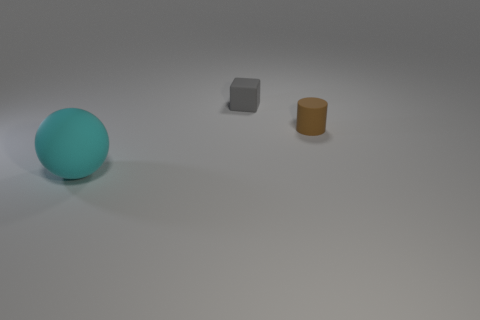How big is the matte ball?
Provide a short and direct response. Large. Are there more balls that are in front of the cylinder than purple rubber spheres?
Ensure brevity in your answer.  Yes. Are there an equal number of brown matte cylinders that are left of the small brown rubber cylinder and matte objects that are on the left side of the gray matte object?
Offer a very short reply. No. The object that is in front of the tiny matte cube and on the left side of the small brown cylinder is what color?
Your response must be concise. Cyan. Is there any other thing that has the same size as the sphere?
Your response must be concise. No. Is the number of small things on the left side of the brown object greater than the number of tiny rubber things that are in front of the cyan sphere?
Provide a short and direct response. Yes. There is a rubber thing right of the matte block; is it the same size as the cyan rubber sphere?
Your response must be concise. No. How many cyan balls are on the left side of the tiny thing that is in front of the object behind the tiny brown rubber object?
Your answer should be very brief. 1. There is a thing that is both behind the cyan rubber sphere and on the left side of the brown rubber cylinder; what size is it?
Provide a short and direct response. Small. How many other objects are there of the same shape as the small gray object?
Provide a short and direct response. 0. 